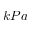<formula> <loc_0><loc_0><loc_500><loc_500>k P a</formula> 